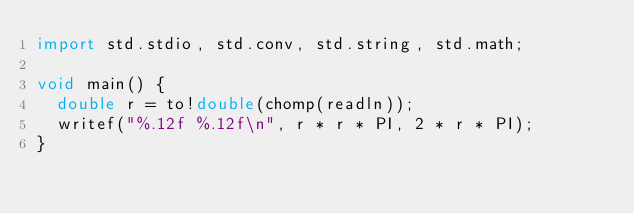<code> <loc_0><loc_0><loc_500><loc_500><_D_>import std.stdio, std.conv, std.string, std.math;

void main() {
  double r = to!double(chomp(readln));
  writef("%.12f %.12f\n", r * r * PI, 2 * r * PI);
}</code> 